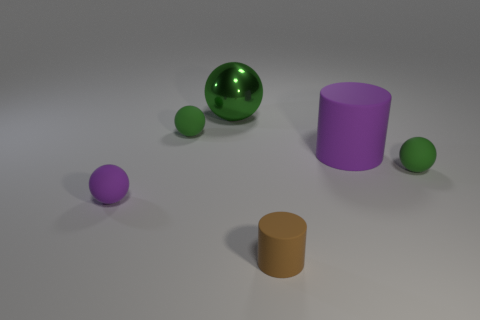Subtract all green balls. How many were subtracted if there are1green balls left? 2 Subtract all green cylinders. How many green spheres are left? 3 Add 2 cubes. How many objects exist? 8 Subtract all spheres. How many objects are left? 2 Subtract 0 blue cylinders. How many objects are left? 6 Subtract all small brown cylinders. Subtract all big brown shiny cubes. How many objects are left? 5 Add 2 green spheres. How many green spheres are left? 5 Add 5 blue rubber objects. How many blue rubber objects exist? 5 